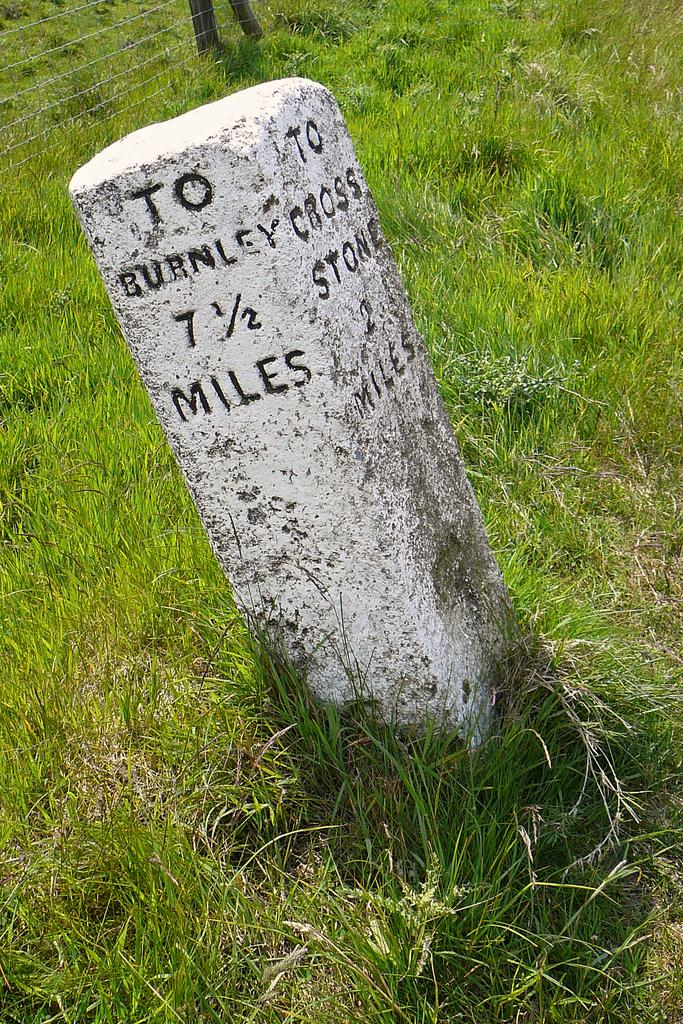What is the main object in the foreground of the image? There is a pillar with text in the image. How is the pillar positioned in relation to the image? The pillar is in front of the image. What type of vegetation can be seen at the bottom of the image? There is grass on the surface at the bottom of the image. What architectural feature can be seen in the background of the image? There is a fence in the background of the image. Where is the sack of milk placed in the wilderness in the image? There is no sack of milk or wilderness present in the image. 